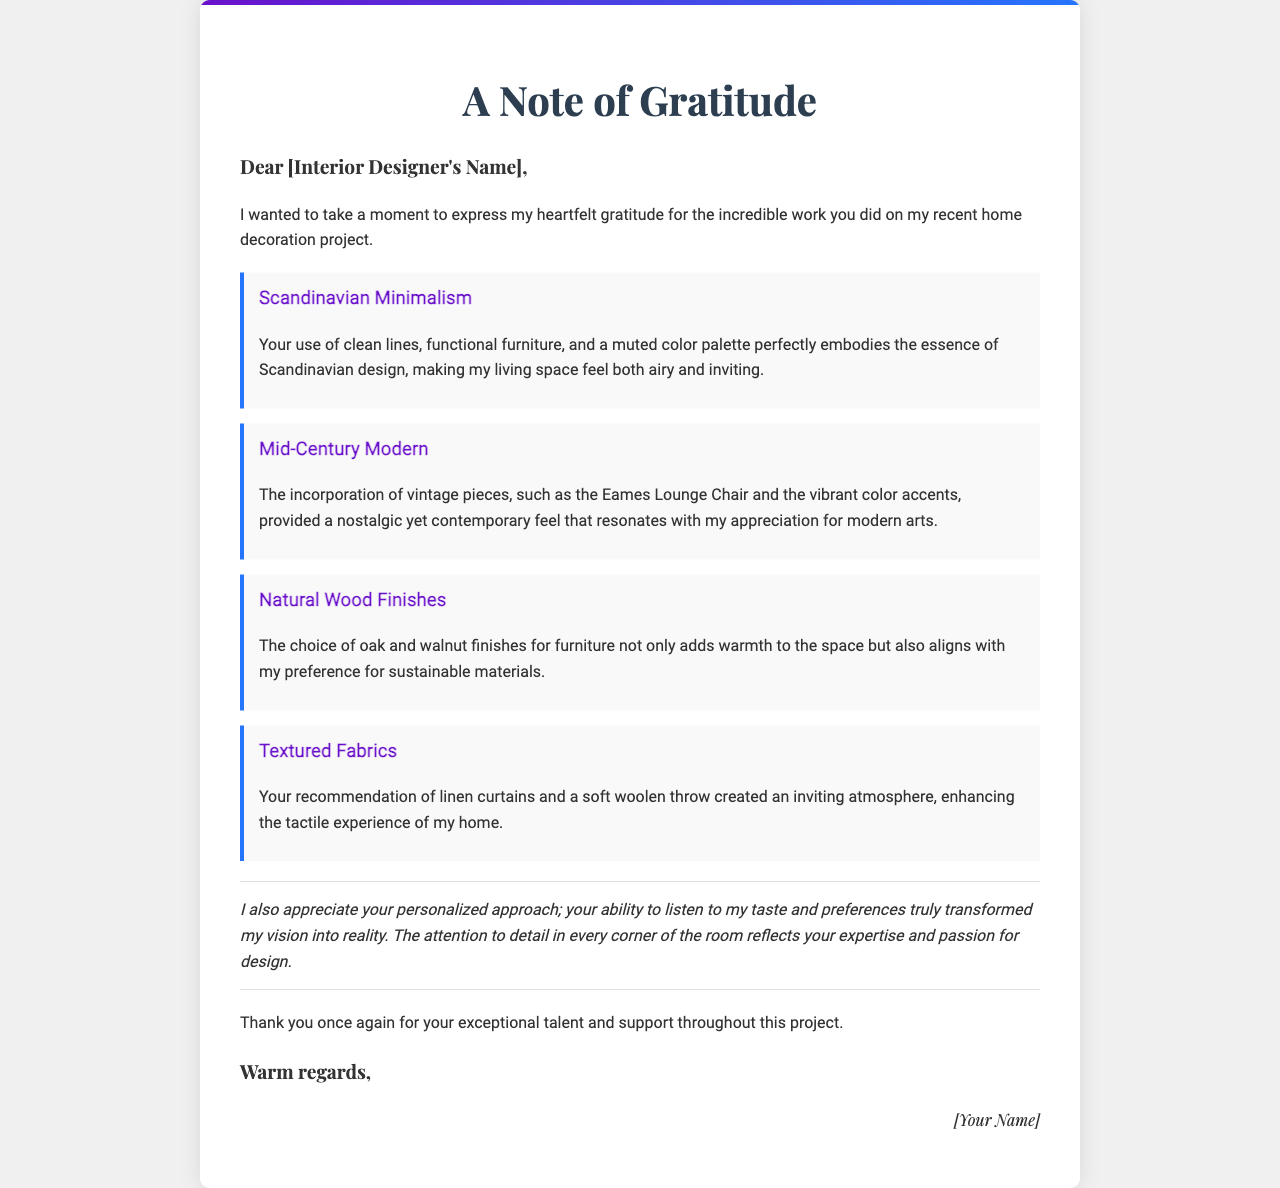What is the title of the letter? The title of the letter is prominently displayed at the top, which indicates the topic of the communication.
Answer: A Note of Gratitude Who is the letter addressed to? The salutation clearly specifies the recipient of the letter, which is the interior designer.
Answer: [Interior Designer's Name] What design style is mentioned first in the document? The first design inspiration mentioned in the document reflects a specific aesthetic that was appreciated by the writer.
Answer: Scandinavian Minimalism Which fabric types were recommended for creating an inviting atmosphere? The document lists specific materials recommended by the interior designer to enhance the home’s atmosphere.
Answer: Linen curtains and a soft woolen throw What is one element of Mid-Century Modern style mentioned? The document cites a particular piece that embodies the Mid-Century Modern style, which reflects nostalgia and contemporary design.
Answer: Eames Lounge Chair How does the author describe the choice of materials? The author explains how the selected materials align with their personal values and preferences regarding sustainability.
Answer: Sustainable materials What overall impression does the author convey about the designer's work? The author expresses a general sentiment regarding the designer's contribution to the decoration project based on the detailed reflections shared in the letter.
Answer: Exceptional talent What is the closing phrase of the letter? The closing phrase summarizes the author’s sentiment at the end of the correspondence, providing a formal end to the communication.
Answer: Warm regards 